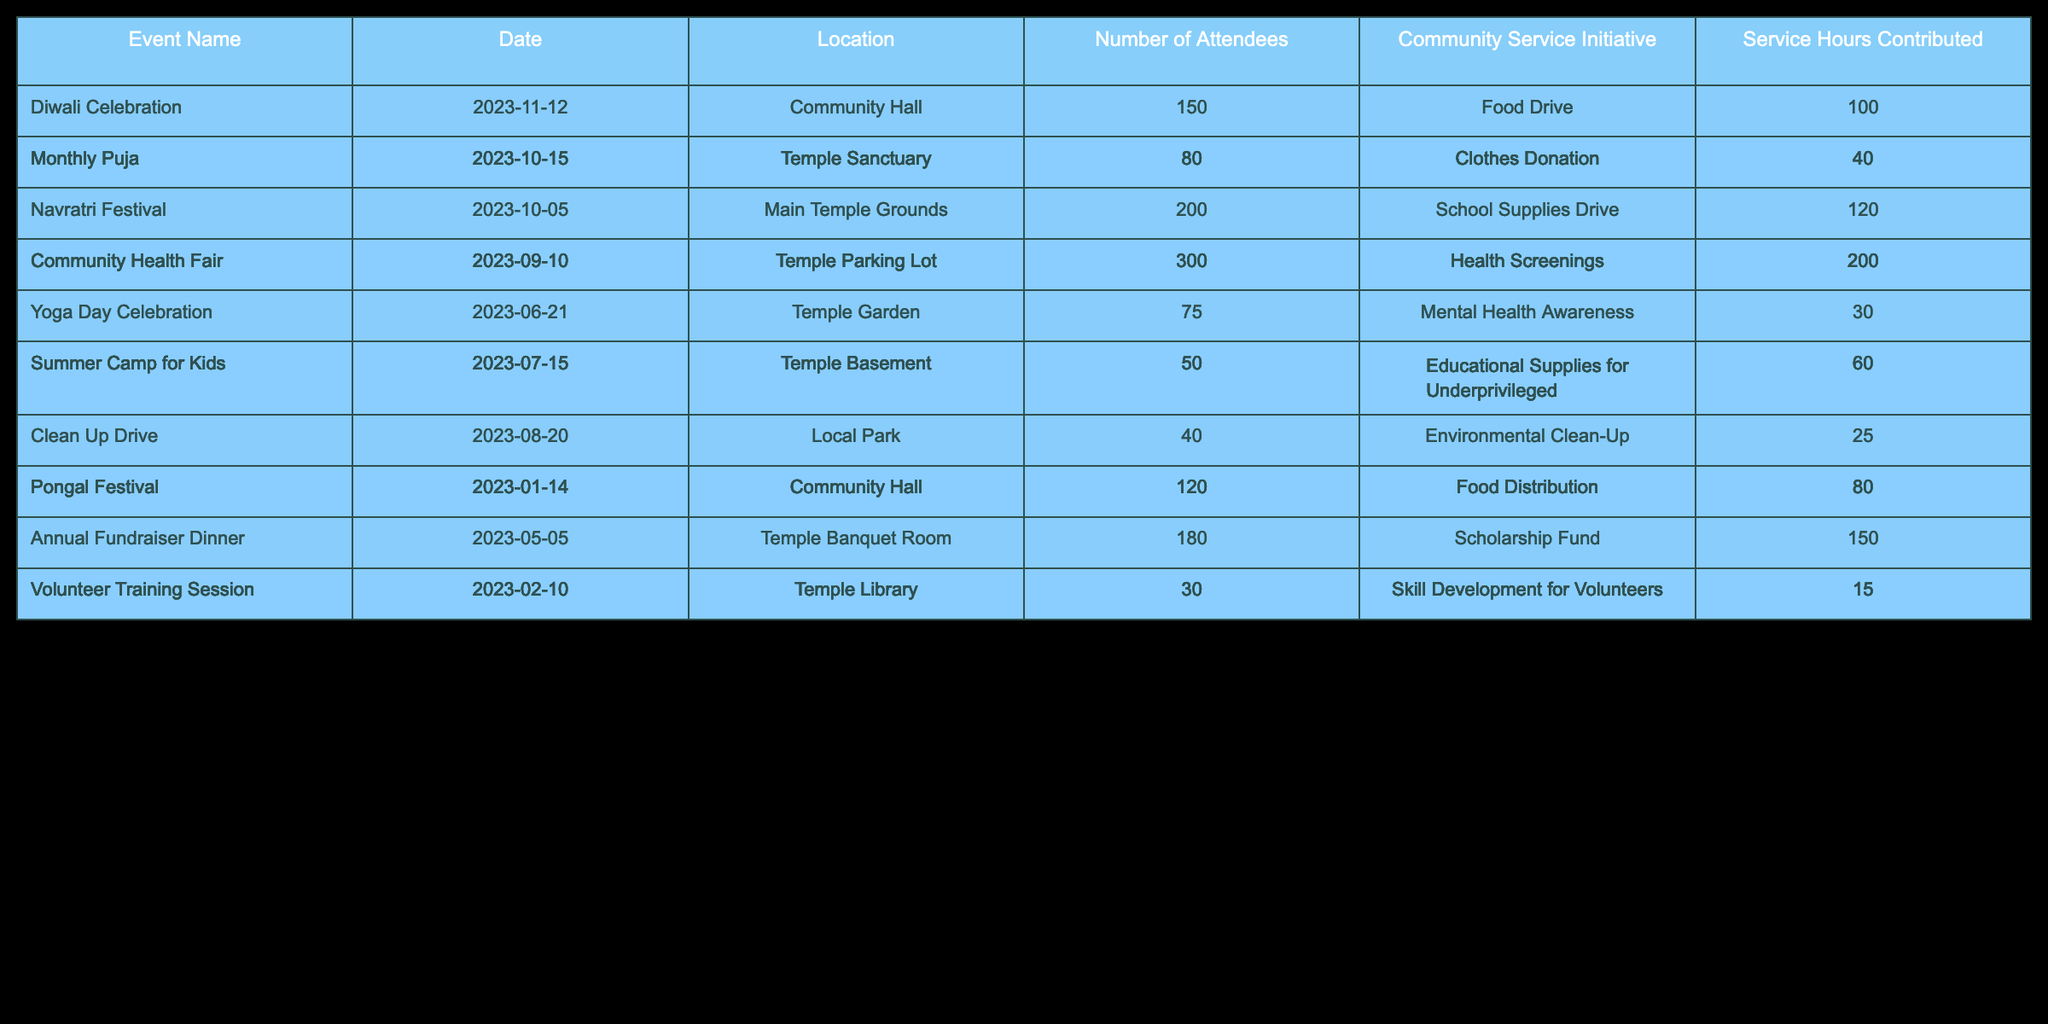What was the total number of attendees across all events? To find the total number of attendees, I will sum the "Number of Attendees" column. The values are: 150 (Diwali Celebration) + 80 (Monthly Puja) + 200 (Navratri Festival) + 300 (Community Health Fair) + 75 (Yoga Day Celebration) + 50 (Summer Camp for Kids) + 40 (Clean Up Drive) + 120 (Pongal Festival) + 180 (Annual Fundraiser Dinner) + 30 (Volunteer Training Session) = 1,325.
Answer: 1325 Which community service initiative had the highest service hours contributed? By examining the "Service Hours Contributed" column, the initiatives and their hours are: Food Drive (100), Clothes Donation (40), School Supplies Drive (120), Health Screenings (200), Mental Health Awareness (30), Educational Supplies for Underprivileged (60), Environmental Clean-Up (25), Food Distribution (80), Scholarship Fund (150), Skill Development for Volunteers (15). The highest value is 200 for Health Screenings.
Answer: Health Screenings Was the average number of attendees higher for events held in the Community Hall compared to events held in the Temple Sanctuary? There are two events in the Community Hall: Diwali Celebration (150) and Pongal Festival (120). Their average is (150 + 120) / 2 = 135. In the Temple Sanctuary, there is only the Monthly Puja with 80 attendees, so the average is 80. Since 135 is greater than 80, the average is indeed higher for the Community Hall events.
Answer: Yes How many total service hours were contributed by initiatives related to food? The food-related initiatives and their service hours are: Food Drive (100), Food Distribution (80). Summing these gives: 100 + 80 = 180.
Answer: 180 Does the Monthly Puja have more attendees than the Yoga Day Celebration? The Monthly Puja had 80 attendees and the Yoga Day Celebration had 75 attendees. Since 80 is greater than 75, the Monthly Puja had more attendees than the Yoga Day Celebration.
Answer: Yes What is the combined total of service hours for the events that took place in the Temple Garden and the Temple Library? Events held in the Temple Garden and Temple Library are Yoga Day Celebration (30 service hours) and Volunteer Training Session (15 service hours), respectively. Adding these gives: 30 + 15 = 45.
Answer: 45 Which event had the fewest attendees and what was the corresponding community service initiative? Looking at the "Number of Attendees", the event with the fewest attendees is the Clean Up Drive with 40 attendees. The community service initiative linked to it is Environmental Clean-Up.
Answer: Environmental Clean-Up What percentage of the total service hours contributed came from the Community Health Fair? The service hours for the Community Health Fair is 200. The total service hours contributed from all events is the sum of all service hours: 100 + 40 + 120 + 200 + 30 + 60 + 25 + 80 + 150 + 15 = 810. To find the percentage: (200 / 810) * 100 = approximately 24.69%.
Answer: 24.69% 